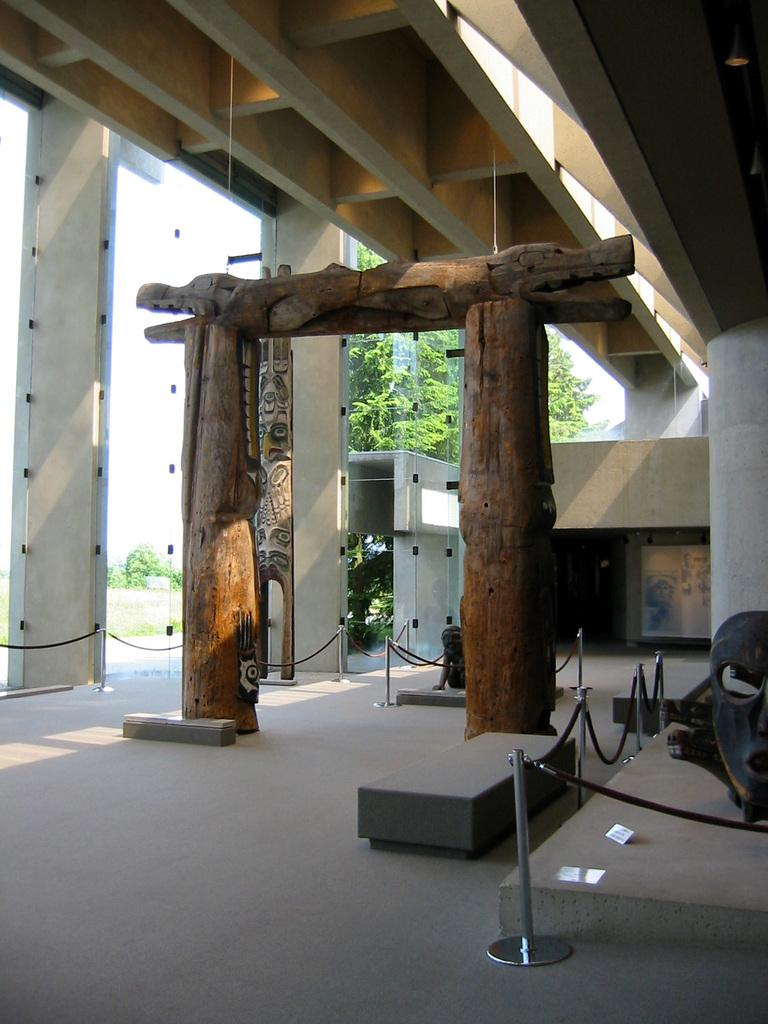What structure is located at the front of the image? There is an arch in the front of the image. What objects are in the middle of the image? There are glasses in the middle of the image. What type of natural scenery is visible in the background of the image? There are trees in the background of the image. What can be seen on the right side of the image? There is a queue manager on the right side of the image. Where is the hose located in the image? There is no hose present in the image. What type of wind can be seen blowing through the trees in the image? There is no wind visible in the image, and the type of wind cannot be determined from the image. 